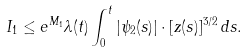<formula> <loc_0><loc_0><loc_500><loc_500>I _ { 1 } \leq e ^ { M _ { 1 } } \lambda ( t ) \int _ { 0 } ^ { t } | \psi _ { 2 } ( s ) | \cdot [ z ( s ) ] ^ { 3 / 2 } \, d s .</formula> 